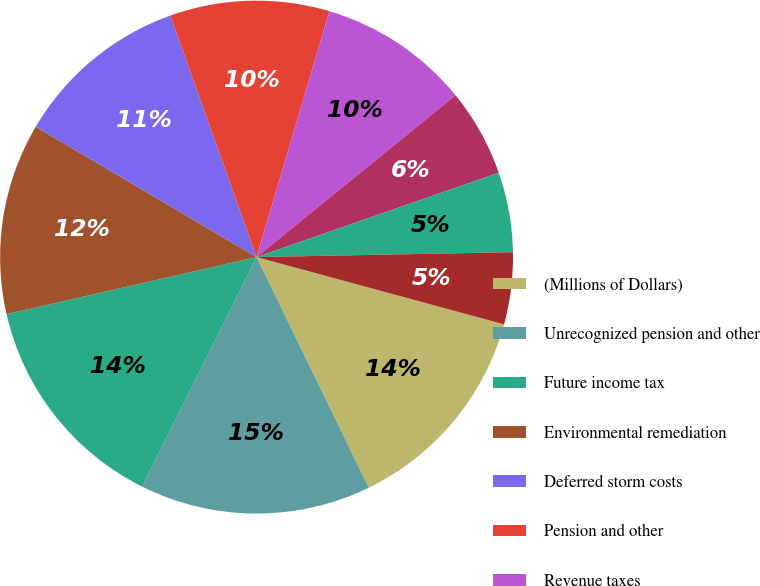Convert chart. <chart><loc_0><loc_0><loc_500><loc_500><pie_chart><fcel>(Millions of Dollars)<fcel>Unrecognized pension and other<fcel>Future income tax<fcel>Environmental remediation<fcel>Deferred storm costs<fcel>Pension and other<fcel>Revenue taxes<fcel>Net electric deferrals<fcel>Surcharge for New York State<fcel>Unamortized loss on reacquired<nl><fcel>13.57%<fcel>14.57%<fcel>14.07%<fcel>12.06%<fcel>11.05%<fcel>10.05%<fcel>9.55%<fcel>5.53%<fcel>5.03%<fcel>4.53%<nl></chart> 